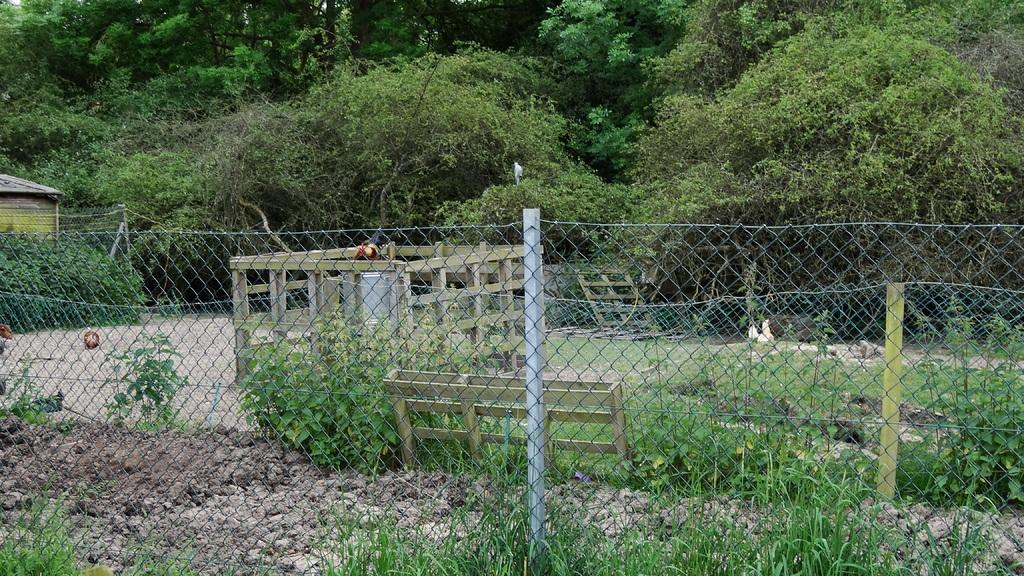What type of structure can be seen on the left side of the image? There is a building on the left side of the image. What is located in front of the building? A fence is visible in the image. What type of vegetation is present in the image? There are plants and trees in the image. What is the ground made of in the image? Soil is visible in the image. Can you see a twig being used as a whip in the image? There is no twig or whip present in the image. What type of field is visible in the background of the image? There is no field visible in the image; it features a building, fence, plants, soil, and trees. 